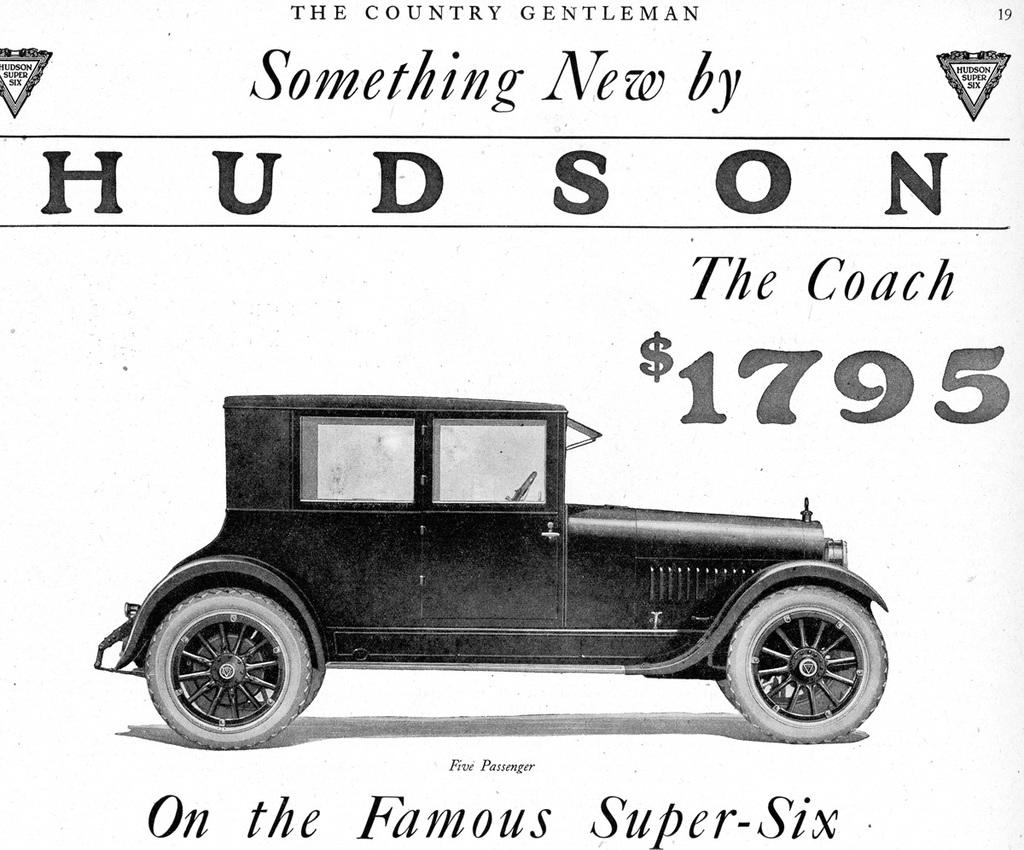What type of visual is the image? The image is a poster. What is the main subject of the poster? There is a vehicle depicted on the poster. Are there any additional elements on the poster besides the vehicle? Yes, there are symbols and text on the poster. Can you see a robin perched on the vehicle in the poster? There is no robin present in the image; it only features a vehicle, symbols, and text. What type of potato is shown growing near the vehicle in the poster? There is no potato present in the image; it only features a vehicle, symbols, and text. 